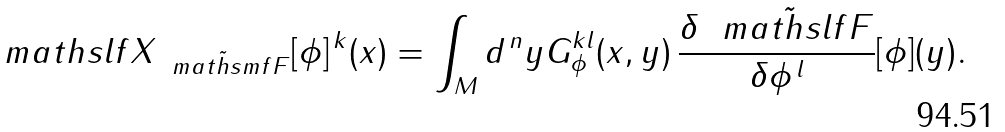<formula> <loc_0><loc_0><loc_500><loc_500>\ m a t h s l f { X } _ { \, \tilde { \, \ m a t h s m f { F } } } [ \phi ] ^ { \, k } ( x ) = \int _ { M } d ^ { \, n } y G _ { \phi } ^ { k l } ( x , y ) \, \frac { \delta \, \tilde { \, \ m a t h s l f { F } } } { \delta \phi ^ { \, l } } [ \phi ] ( y ) .</formula> 